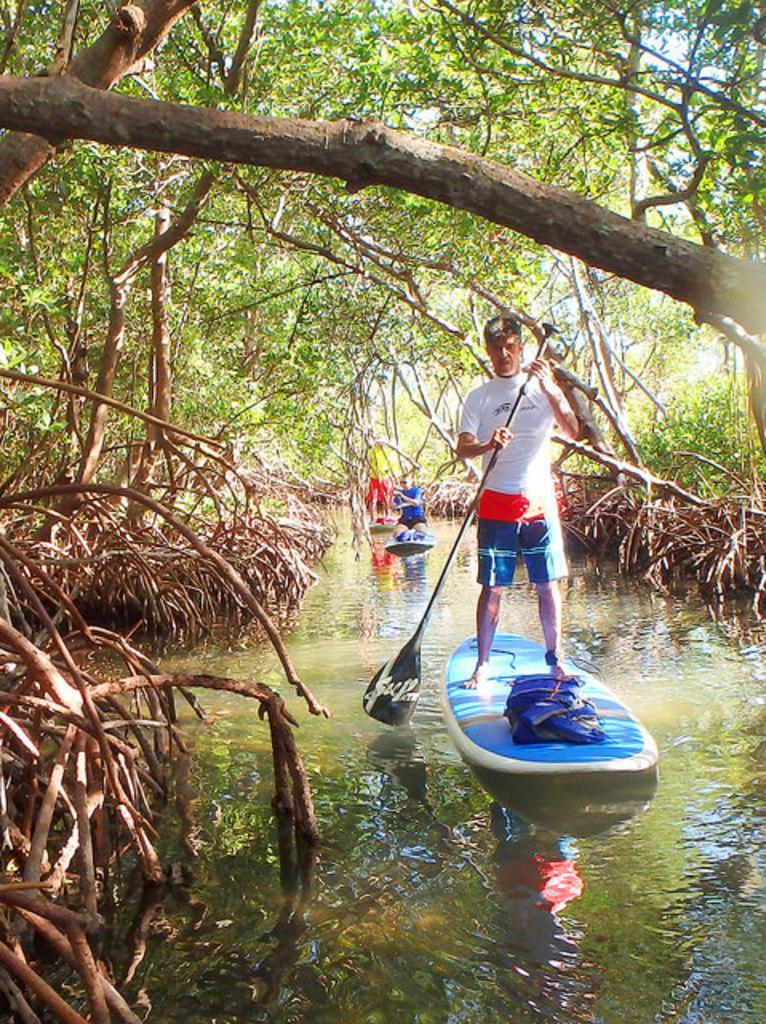How would you summarize this image in a sentence or two? In this image there are people doing boating in the water beside them there are so many trees. 